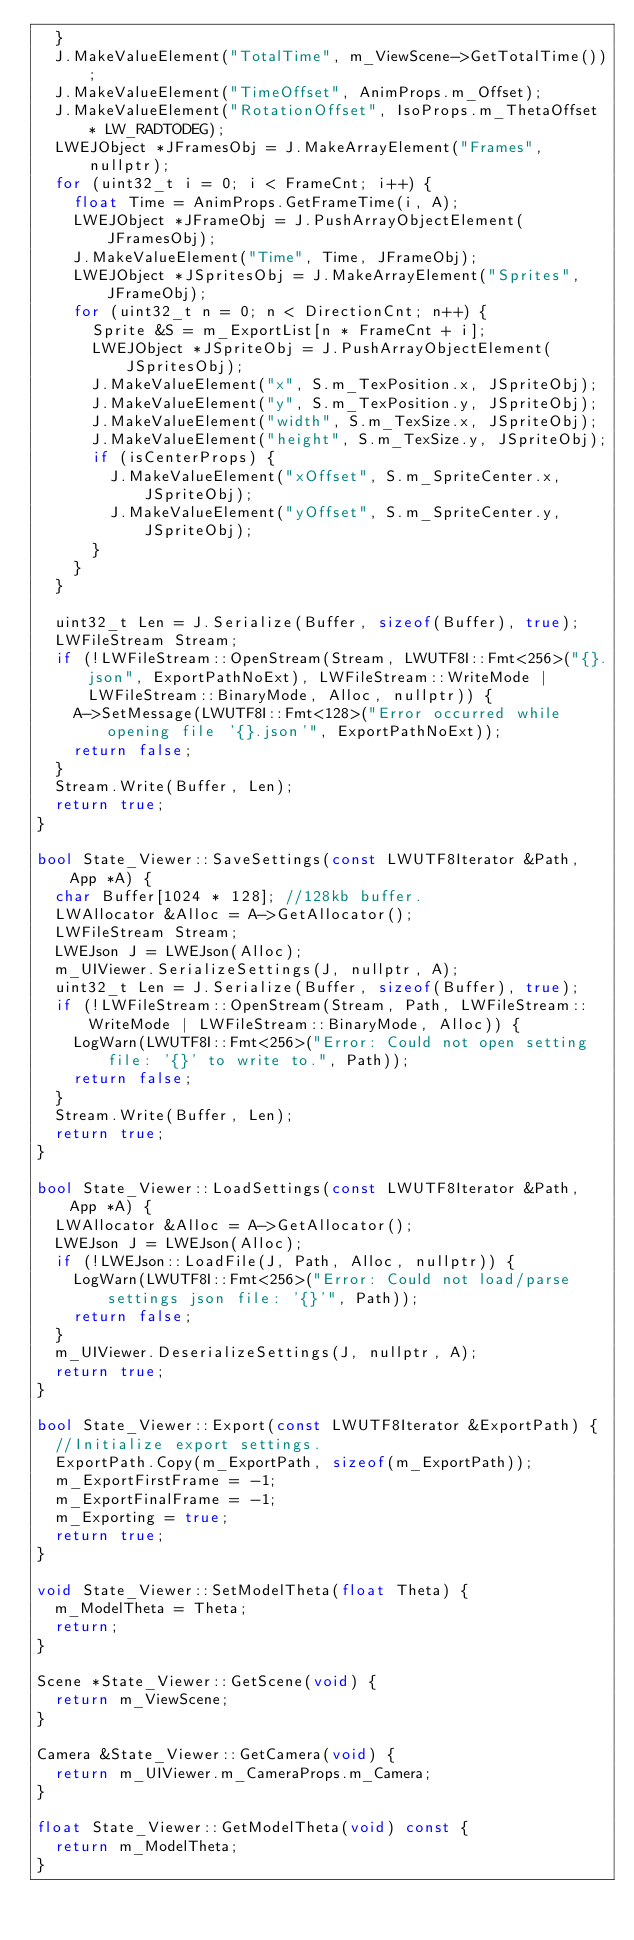Convert code to text. <code><loc_0><loc_0><loc_500><loc_500><_C++_>	}
	J.MakeValueElement("TotalTime", m_ViewScene->GetTotalTime());
	J.MakeValueElement("TimeOffset", AnimProps.m_Offset);
	J.MakeValueElement("RotationOffset", IsoProps.m_ThetaOffset * LW_RADTODEG);
	LWEJObject *JFramesObj = J.MakeArrayElement("Frames", nullptr);
	for (uint32_t i = 0; i < FrameCnt; i++) {
		float Time = AnimProps.GetFrameTime(i, A);
		LWEJObject *JFrameObj = J.PushArrayObjectElement(JFramesObj);
		J.MakeValueElement("Time", Time, JFrameObj);
		LWEJObject *JSpritesObj = J.MakeArrayElement("Sprites", JFrameObj);
		for (uint32_t n = 0; n < DirectionCnt; n++) {
			Sprite &S = m_ExportList[n * FrameCnt + i];
			LWEJObject *JSpriteObj = J.PushArrayObjectElement(JSpritesObj);
			J.MakeValueElement("x", S.m_TexPosition.x, JSpriteObj);
			J.MakeValueElement("y", S.m_TexPosition.y, JSpriteObj);
			J.MakeValueElement("width", S.m_TexSize.x, JSpriteObj);
			J.MakeValueElement("height", S.m_TexSize.y, JSpriteObj);
			if (isCenterProps) {
				J.MakeValueElement("xOffset", S.m_SpriteCenter.x, JSpriteObj);
				J.MakeValueElement("yOffset", S.m_SpriteCenter.y, JSpriteObj);
			}
		}
	}

	uint32_t Len = J.Serialize(Buffer, sizeof(Buffer), true);
	LWFileStream Stream;
	if (!LWFileStream::OpenStream(Stream, LWUTF8I::Fmt<256>("{}.json", ExportPathNoExt), LWFileStream::WriteMode | LWFileStream::BinaryMode, Alloc, nullptr)) {
		A->SetMessage(LWUTF8I::Fmt<128>("Error occurred while opening file '{}.json'", ExportPathNoExt));
		return false;
	}
	Stream.Write(Buffer, Len);
	return true;
}

bool State_Viewer::SaveSettings(const LWUTF8Iterator &Path, App *A) {
	char Buffer[1024 * 128]; //128kb buffer.
	LWAllocator &Alloc = A->GetAllocator();
	LWFileStream Stream;
	LWEJson J = LWEJson(Alloc);
	m_UIViewer.SerializeSettings(J, nullptr, A);
	uint32_t Len = J.Serialize(Buffer, sizeof(Buffer), true);
	if (!LWFileStream::OpenStream(Stream, Path, LWFileStream::WriteMode | LWFileStream::BinaryMode, Alloc)) {
		LogWarn(LWUTF8I::Fmt<256>("Error: Could not open setting file: '{}' to write to.", Path));
		return false;
	}
	Stream.Write(Buffer, Len);
	return true;
}

bool State_Viewer::LoadSettings(const LWUTF8Iterator &Path, App *A) {
	LWAllocator &Alloc = A->GetAllocator();
	LWEJson J = LWEJson(Alloc);
	if (!LWEJson::LoadFile(J, Path, Alloc, nullptr)) {
		LogWarn(LWUTF8I::Fmt<256>("Error: Could not load/parse settings json file: '{}'", Path));
		return false;
	}
	m_UIViewer.DeserializeSettings(J, nullptr, A);
	return true;
}

bool State_Viewer::Export(const LWUTF8Iterator &ExportPath) {
	//Initialize export settings.
	ExportPath.Copy(m_ExportPath, sizeof(m_ExportPath));
	m_ExportFirstFrame = -1;
	m_ExportFinalFrame = -1;
	m_Exporting = true;
	return true;
}

void State_Viewer::SetModelTheta(float Theta) {
	m_ModelTheta = Theta;
	return;
}

Scene *State_Viewer::GetScene(void) {
	return m_ViewScene;
}

Camera &State_Viewer::GetCamera(void) {
	return m_UIViewer.m_CameraProps.m_Camera;
}

float State_Viewer::GetModelTheta(void) const {
	return m_ModelTheta;
}
</code> 